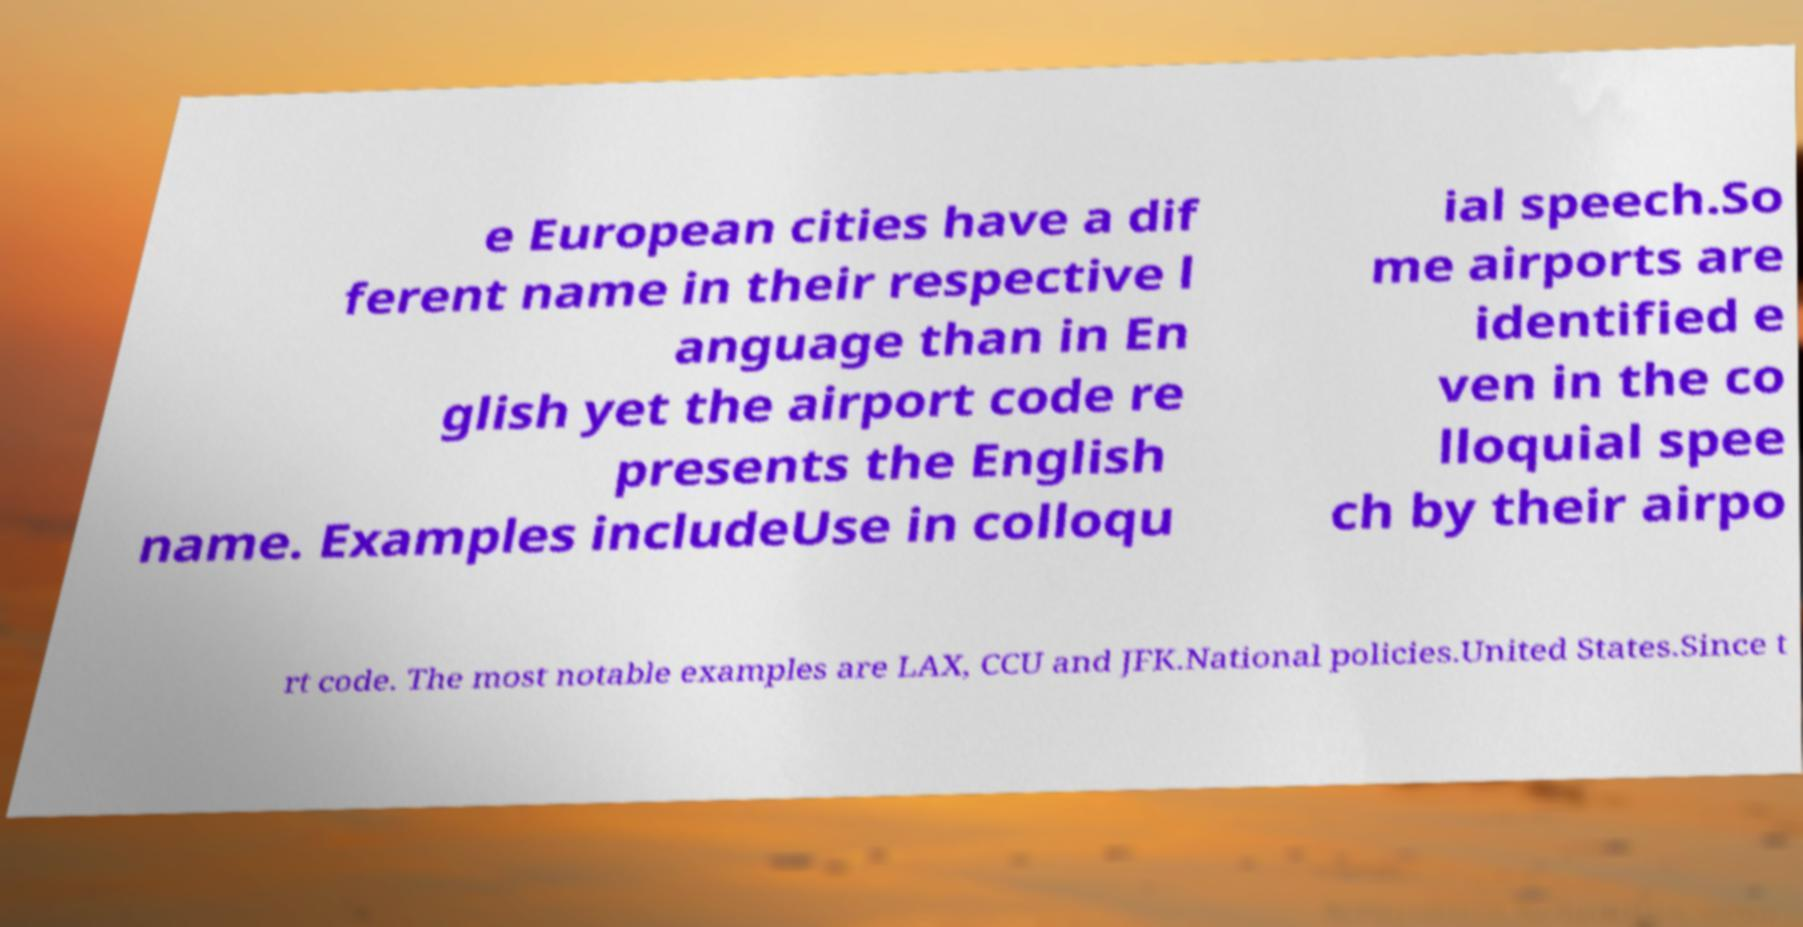Could you extract and type out the text from this image? e European cities have a dif ferent name in their respective l anguage than in En glish yet the airport code re presents the English name. Examples includeUse in colloqu ial speech.So me airports are identified e ven in the co lloquial spee ch by their airpo rt code. The most notable examples are LAX, CCU and JFK.National policies.United States.Since t 